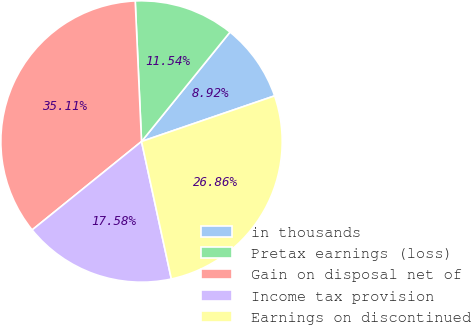<chart> <loc_0><loc_0><loc_500><loc_500><pie_chart><fcel>in thousands<fcel>Pretax earnings (loss)<fcel>Gain on disposal net of<fcel>Income tax provision<fcel>Earnings on discontinued<nl><fcel>8.92%<fcel>11.54%<fcel>35.11%<fcel>17.58%<fcel>26.86%<nl></chart> 